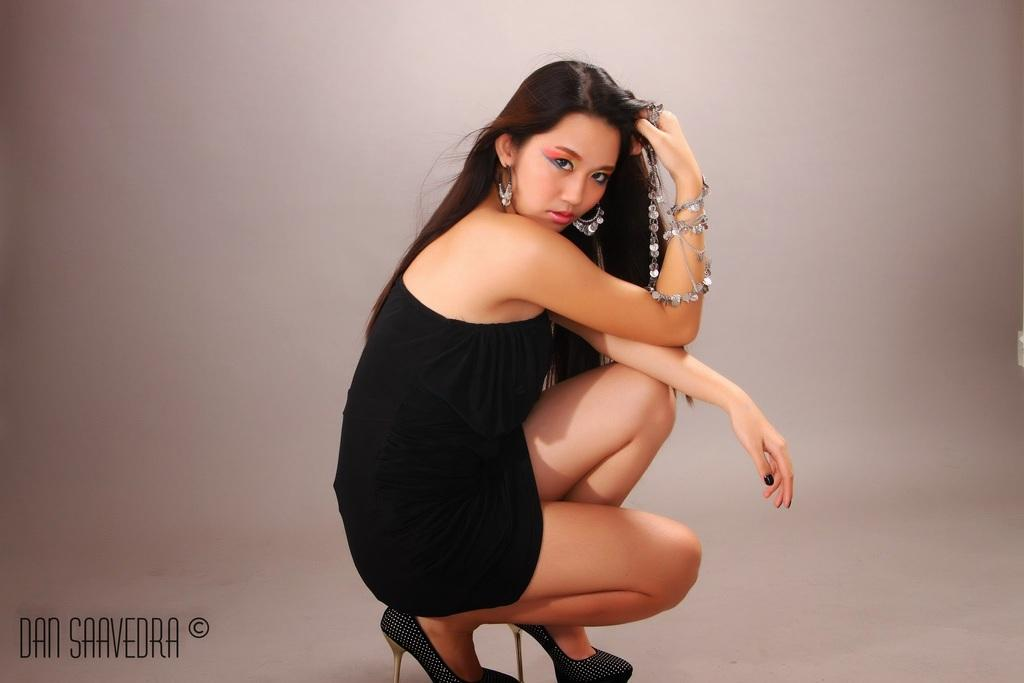Who is the main subject in the image? There is a woman in the image. What is the woman's position in the image? The woman is on a surface. What additional information can be found in the image? There is text visible in the bottom left of the image. What type of monkey is sitting on the tray in the image? There is no monkey or tray present in the image. 